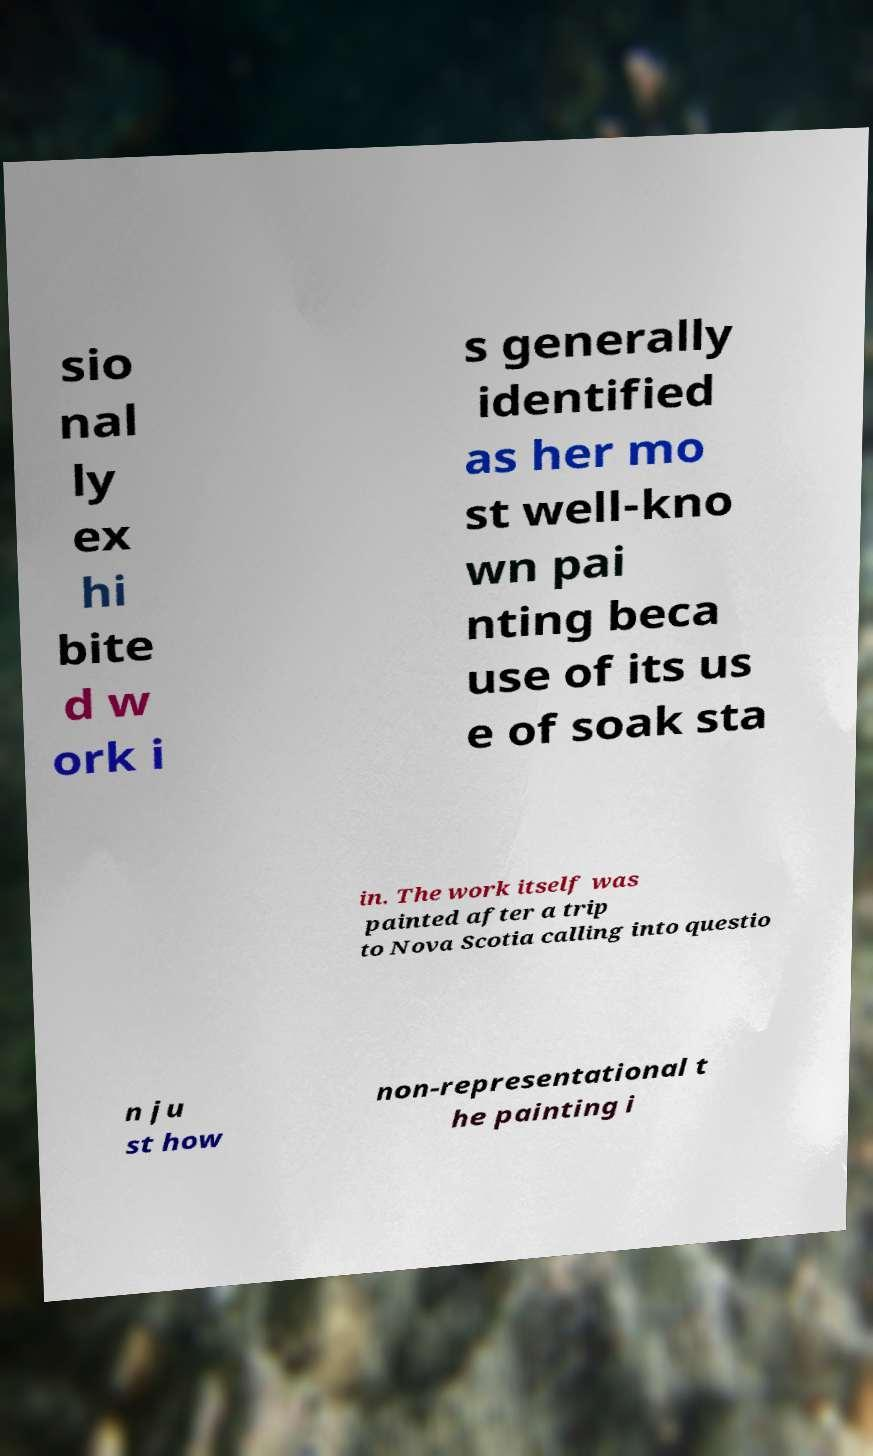Could you extract and type out the text from this image? sio nal ly ex hi bite d w ork i s generally identified as her mo st well-kno wn pai nting beca use of its us e of soak sta in. The work itself was painted after a trip to Nova Scotia calling into questio n ju st how non-representational t he painting i 